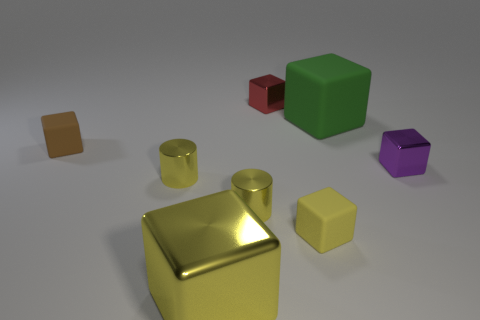Subtract 4 cubes. How many cubes are left? 2 Subtract all brown cubes. How many cubes are left? 5 Subtract all green cubes. How many cubes are left? 5 Subtract all blue cubes. Subtract all purple balls. How many cubes are left? 6 Add 1 red metal things. How many objects exist? 9 Subtract all cylinders. How many objects are left? 6 Subtract all large green blocks. Subtract all large green cubes. How many objects are left? 6 Add 8 large yellow metallic things. How many large yellow metallic things are left? 9 Add 2 purple blocks. How many purple blocks exist? 3 Subtract 1 red blocks. How many objects are left? 7 